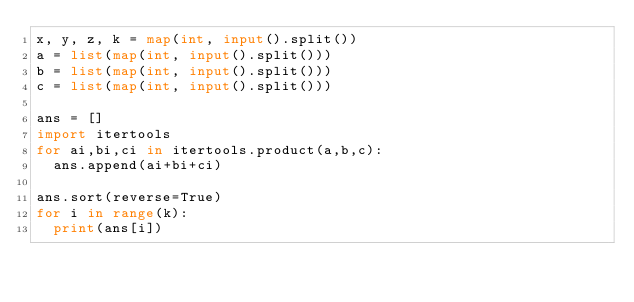<code> <loc_0><loc_0><loc_500><loc_500><_Python_>x, y, z, k = map(int, input().split())
a = list(map(int, input().split()))
b = list(map(int, input().split()))
c = list(map(int, input().split()))

ans = []
import itertools
for ai,bi,ci in itertools.product(a,b,c):
  ans.append(ai+bi+ci)

ans.sort(reverse=True)
for i in range(k):
  print(ans[i])</code> 